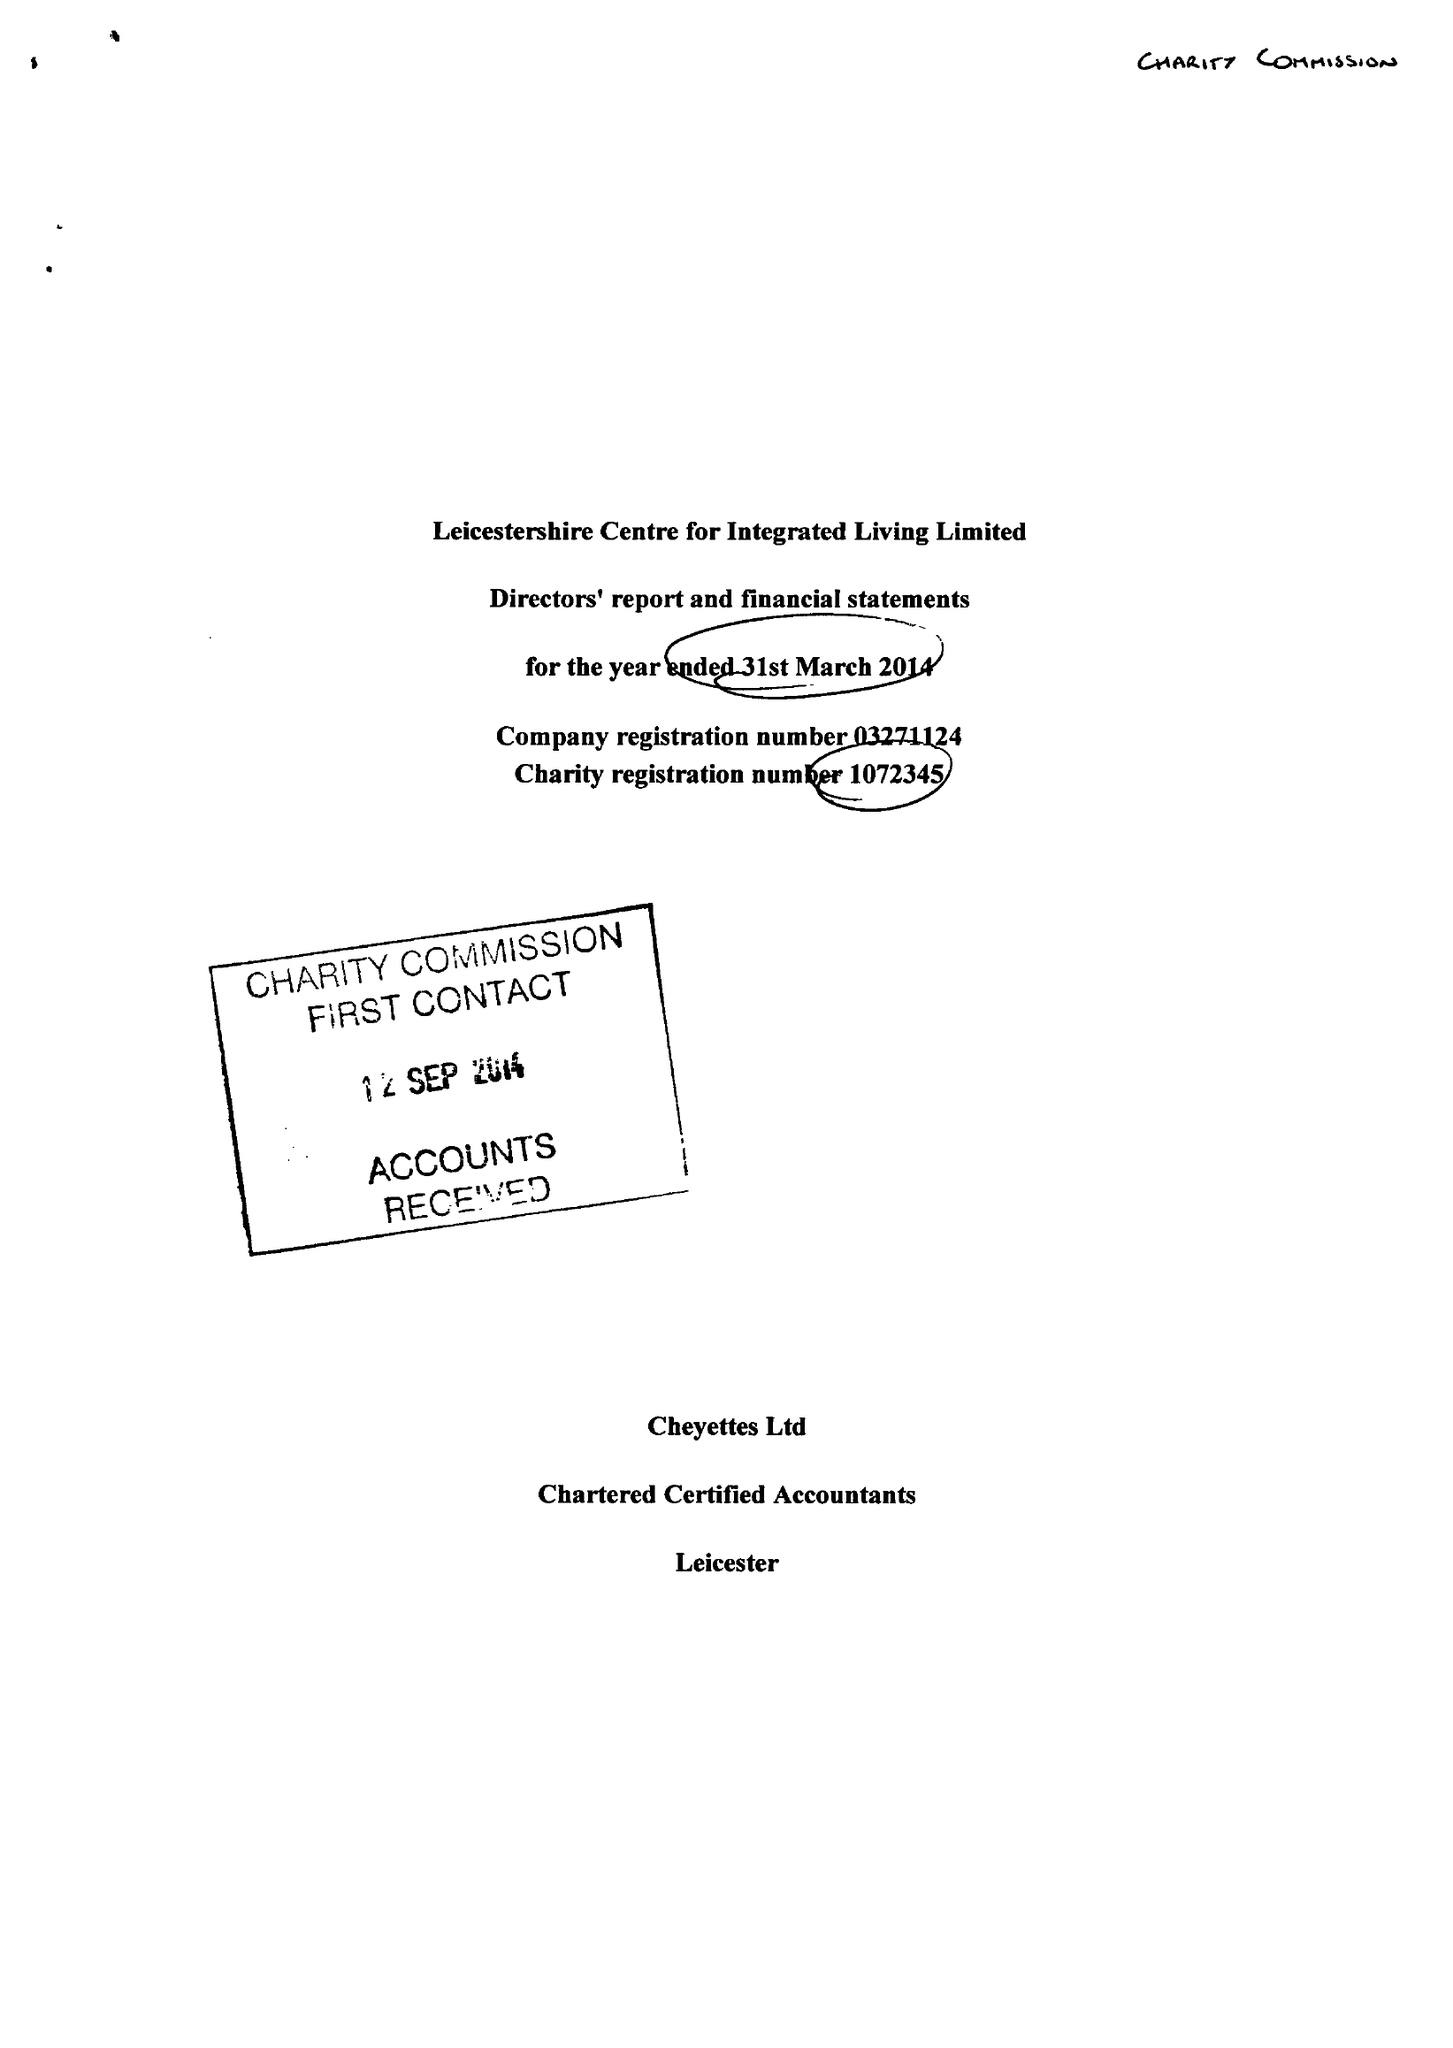What is the value for the address__street_line?
Answer the question using a single word or phrase. ANDREWES STREET 